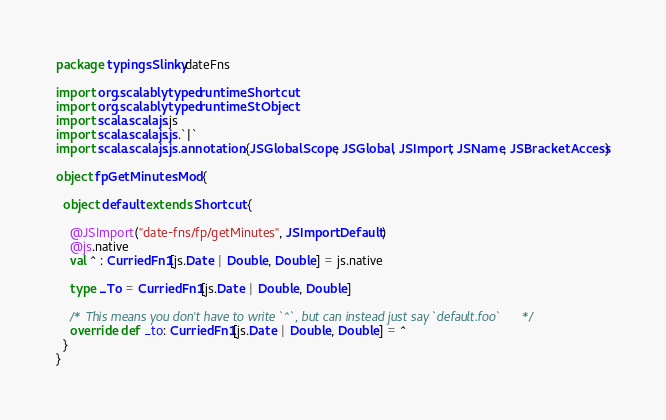<code> <loc_0><loc_0><loc_500><loc_500><_Scala_>package typingsSlinky.dateFns

import org.scalablytyped.runtime.Shortcut
import org.scalablytyped.runtime.StObject
import scala.scalajs.js
import scala.scalajs.js.`|`
import scala.scalajs.js.annotation.{JSGlobalScope, JSGlobal, JSImport, JSName, JSBracketAccess}

object fpGetMinutesMod {
  
  object default extends Shortcut {
    
    @JSImport("date-fns/fp/getMinutes", JSImport.Default)
    @js.native
    val ^ : CurriedFn1[js.Date | Double, Double] = js.native
    
    type _To = CurriedFn1[js.Date | Double, Double]
    
    /* This means you don't have to write `^`, but can instead just say `default.foo` */
    override def _to: CurriedFn1[js.Date | Double, Double] = ^
  }
}
</code> 